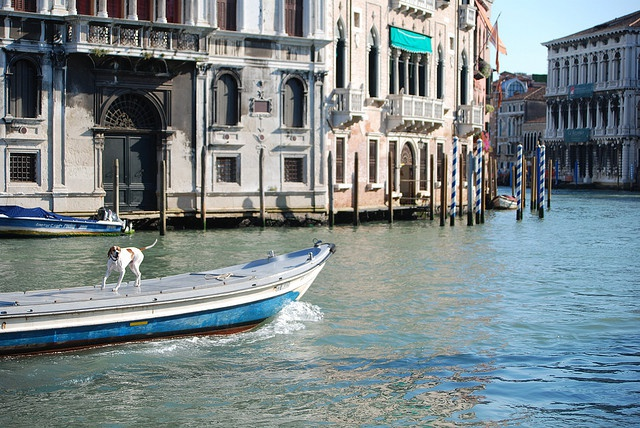Describe the objects in this image and their specific colors. I can see boat in gray, lightgray, darkgray, and black tones, boat in gray, black, navy, and lightgray tones, dog in gray, white, darkgray, and black tones, and boat in gray, black, darkgray, and lightgray tones in this image. 